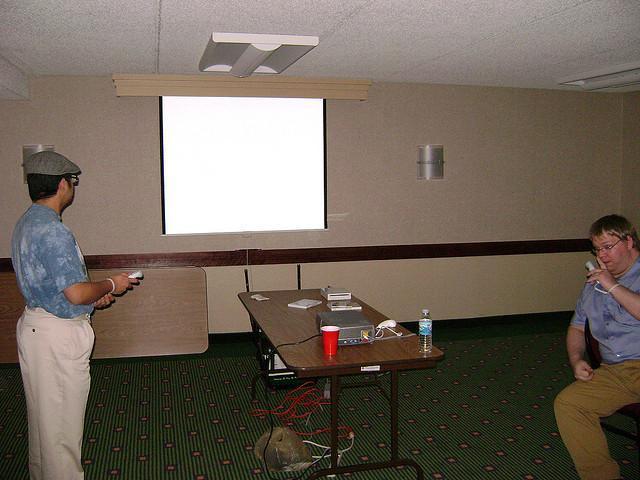How many people are there?
Give a very brief answer. 2. How many dining tables are in the picture?
Give a very brief answer. 2. How many white birds are there?
Give a very brief answer. 0. 